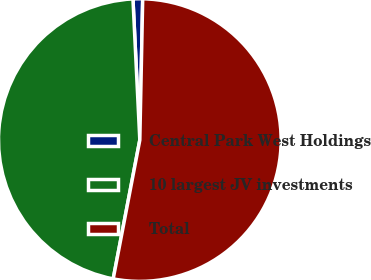<chart> <loc_0><loc_0><loc_500><loc_500><pie_chart><fcel>Central Park West Holdings<fcel>10 largest JV investments<fcel>Total<nl><fcel>1.1%<fcel>46.21%<fcel>52.69%<nl></chart> 